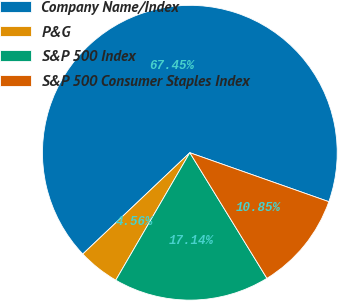Convert chart to OTSL. <chart><loc_0><loc_0><loc_500><loc_500><pie_chart><fcel>Company Name/Index<fcel>P&G<fcel>S&P 500 Index<fcel>S&P 500 Consumer Staples Index<nl><fcel>67.46%<fcel>4.56%<fcel>17.14%<fcel>10.85%<nl></chart> 